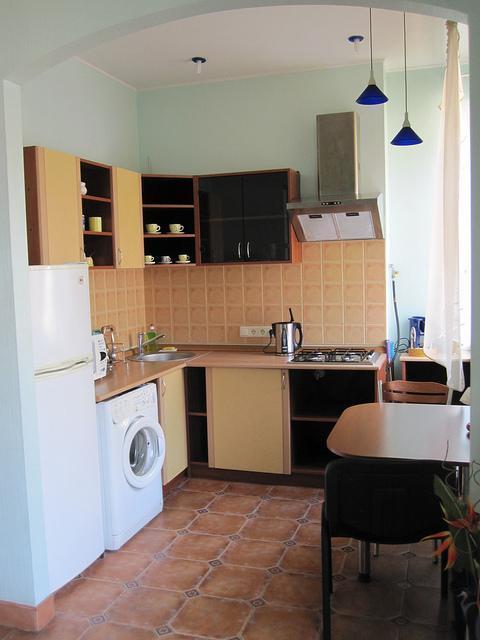How many refrigerators are visible?
Give a very brief answer. 1. 